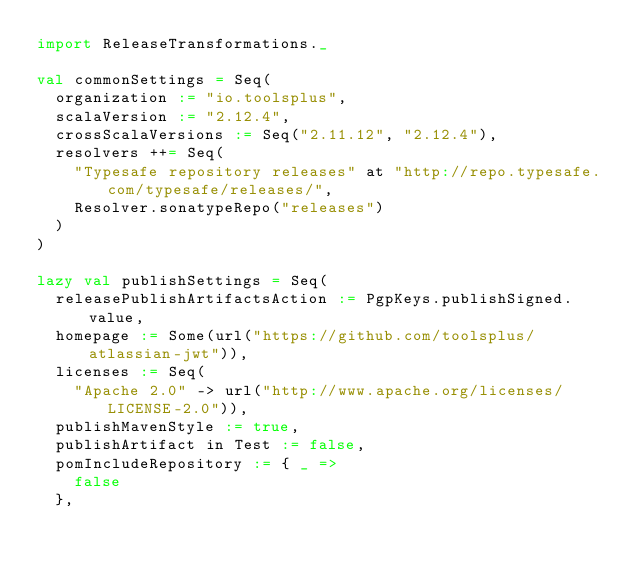<code> <loc_0><loc_0><loc_500><loc_500><_Scala_>import ReleaseTransformations._

val commonSettings = Seq(
  organization := "io.toolsplus",
  scalaVersion := "2.12.4",
  crossScalaVersions := Seq("2.11.12", "2.12.4"),
  resolvers ++= Seq(
    "Typesafe repository releases" at "http://repo.typesafe.com/typesafe/releases/",
    Resolver.sonatypeRepo("releases")
  )
)

lazy val publishSettings = Seq(
  releasePublishArtifactsAction := PgpKeys.publishSigned.value,
  homepage := Some(url("https://github.com/toolsplus/atlassian-jwt")),
  licenses := Seq(
    "Apache 2.0" -> url("http://www.apache.org/licenses/LICENSE-2.0")),
  publishMavenStyle := true,
  publishArtifact in Test := false,
  pomIncludeRepository := { _ =>
    false
  },</code> 